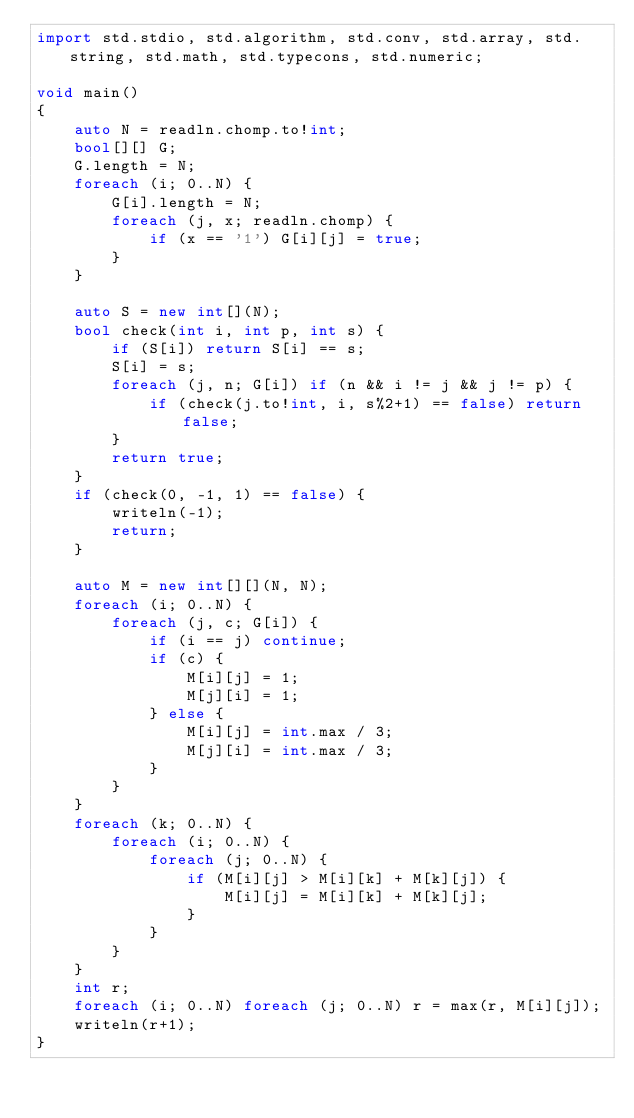<code> <loc_0><loc_0><loc_500><loc_500><_D_>import std.stdio, std.algorithm, std.conv, std.array, std.string, std.math, std.typecons, std.numeric;

void main()
{
    auto N = readln.chomp.to!int;
    bool[][] G;
    G.length = N;
    foreach (i; 0..N) {
        G[i].length = N;
        foreach (j, x; readln.chomp) {
            if (x == '1') G[i][j] = true;
        }
    }

    auto S = new int[](N);
    bool check(int i, int p, int s) {
        if (S[i]) return S[i] == s;
        S[i] = s;
        foreach (j, n; G[i]) if (n && i != j && j != p) {
            if (check(j.to!int, i, s%2+1) == false) return false;
        }
        return true;
    }
    if (check(0, -1, 1) == false) {
        writeln(-1);
        return;
    }

    auto M = new int[][](N, N);
    foreach (i; 0..N) {
        foreach (j, c; G[i]) {
            if (i == j) continue;
            if (c) {
                M[i][j] = 1;
                M[j][i] = 1;
            } else {
                M[i][j] = int.max / 3;
                M[j][i] = int.max / 3;
            }
        }
    }
    foreach (k; 0..N) {
        foreach (i; 0..N) {
            foreach (j; 0..N) {
                if (M[i][j] > M[i][k] + M[k][j]) {
                    M[i][j] = M[i][k] + M[k][j];
                }
            }
        }
    }
    int r;
    foreach (i; 0..N) foreach (j; 0..N) r = max(r, M[i][j]);
    writeln(r+1);
}</code> 